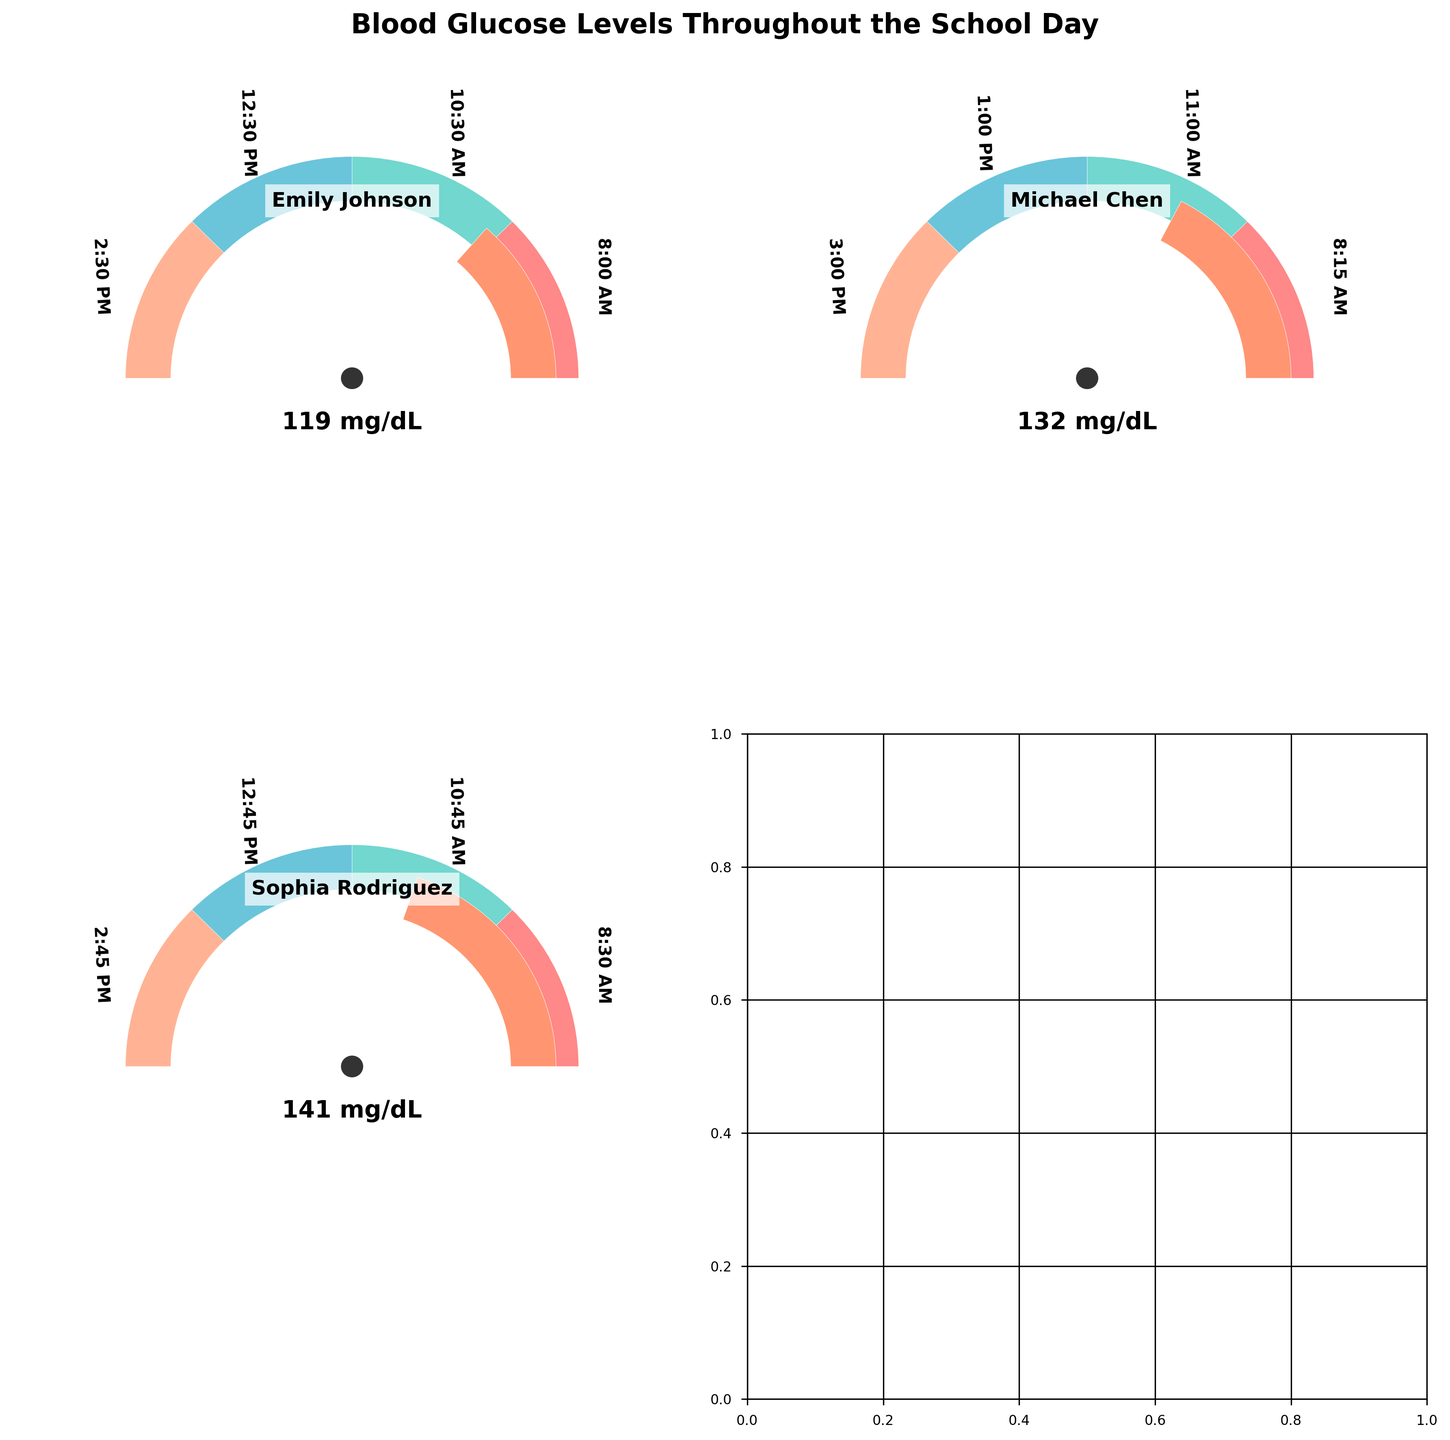What is the title of the figure? The title is usually displayed at the top of the figure and provides a summary of what the figure is about. Here, the title is "Blood Glucose Levels Throughout the School Day."
Answer: Blood Glucose Levels Throughout the School Day How many students' data are shown in the figure? The figure has a separate gauge chart for each student, and we can see the names of the students within each gauge. By counting, we see charts for Emily Johnson, Michael Chen, and Sophia Rodriguez.
Answer: 3 What is the average blood glucose level for Emily Johnson throughout the school day? We need to find the mean of Emily's glucose levels at 8:00 AM (120 mg/dL), 10:30 AM (95 mg/dL), 12:30 PM (150 mg/dL), and 2:30 PM (110 mg/dL). The mean is (120 + 95 + 150 + 110) / 4 = 118.75.
Answer: 119 mg/dL Which student has the highest blood glucose level at any point in the day? To determine this, we need to look at the peak value in each student's gauge chart. By observation, Sophia Rodriguez has the highest level at 12:45 PM with 180 mg/dL.
Answer: Sophia Rodriguez Between Michael Chen and Sophia Rodriguez, who has a higher average blood glucose level throughout the school day? We calculate the average for both students. For Michael: (135 + 105 + 165 + 125) / 4 = 132.5 mg/dL. For Sophia: (140 + 115 + 180 + 130) / 4 = 141.25 mg/dL. Comparing these averages, Sophia has a higher average.
Answer: Sophia Rodriguez What is the blood glucose level for Michael Chen at 1:00 PM? This can be directly read from Michael Chen's gauge chart. At 1:00 PM, the level is marked as 165 mg/dL.
Answer: 165 mg/dL How does Emily Johnson's blood glucose level change from 10:30 AM to 12:30 PM? From the figure, Emily's level at 10:30 AM is 95 mg/dL and at 12:30 PM is 150 mg/dL. The change is 150 - 95, which indicates an increase of 55 mg/dL.
Answer: Increases by 55 mg/dL Is Michael Chen's blood glucose level within the normal range (70-180 mg/dL) throughout the day? By examining Michael’s levels at 8:15 AM (135 mg/dL), 11:00 AM (105 mg/dL), 1:00 PM (165 mg/dL), and 3:00 PM (125 mg/dL), we see all values are within the normal range of 70-180 mg/dL.
Answer: Yes What is the median blood glucose level for Sophia Rodriguez? We first list Sophia's levels as 140, 115, 180, and 130 mg/dL. Ordering these levels: 115, 130, 140, and 180. The median of these values (middle two values) is (130 + 140) / 2 = 135 mg/dL.
Answer: 135 mg/dL 